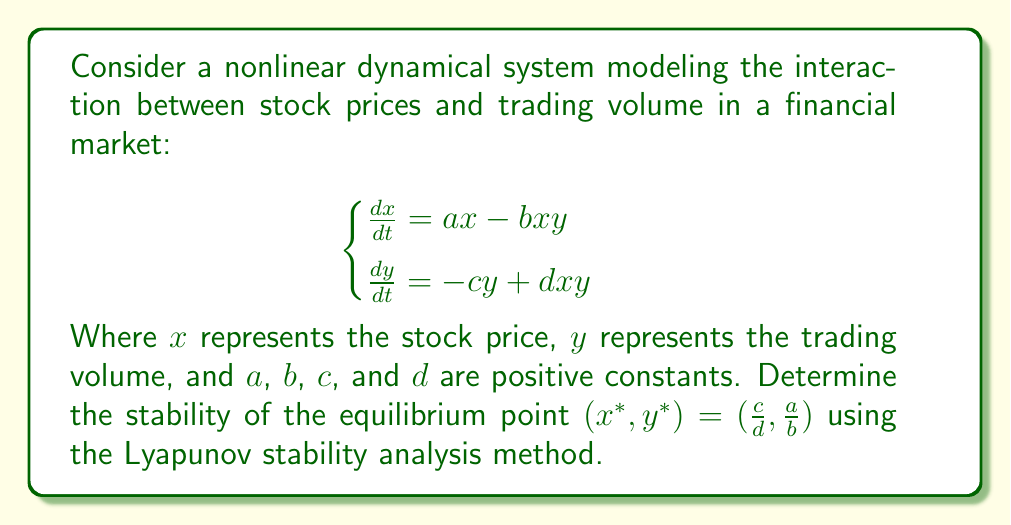Could you help me with this problem? To analyze the stability of the equilibrium point using Lyapunov's method, we'll follow these steps:

1) First, let's define a Lyapunov function candidate:

   $$V(x,y) = \frac{1}{2}(x - x^*)^2 + \frac{1}{2}(y - y^*)^2$$

2) Calculate the time derivative of V:

   $$\frac{dV}{dt} = (x - x^*)\frac{dx}{dt} + (y - y^*)\frac{dy}{dt}$$

3) Substitute the system equations:

   $$\frac{dV}{dt} = (x - x^*)(ax - bxy) + (y - y^*)(-cy + dxy)$$

4) Substitute the equilibrium point values:

   $$\frac{dV}{dt} = (x - \frac{c}{d})(ax - bxy) + (y - \frac{a}{b})(-cy + dxy)$$

5) Expand and simplify:

   $$\begin{align}
   \frac{dV}{dt} &= ax^2 - \frac{ac}{d}x - bx^2y + \frac{bc}{d}xy - cy^2 + \frac{ac}{b}y + dx^2y - \frac{ad}{b}xy \\
   &= ax^2 - \frac{ac}{d}x - cy^2 + \frac{ac}{b}y + (d-b)x^2y + (\frac{bc}{d} - \frac{ad}{b})xy
   \end{align}$$

6) For stability, we need $\frac{dV}{dt} < 0$ for all $(x,y)$ in a neighborhood of $(x^*, y^*)$. This condition is satisfied if:

   a) $d < b$ (ensures the $x^2y$ term is negative)
   b) $\frac{bc}{d} < \frac{ad}{b}$ (ensures the $xy$ term is negative)

7) If these conditions are met, then the equilibrium point is asymptotically stable.
Answer: The equilibrium point $(x^*, y^*) = (\frac{c}{d}, \frac{a}{b})$ is asymptotically stable if $d < b$ and $\frac{bc}{d} < \frac{ad}{b}$. 